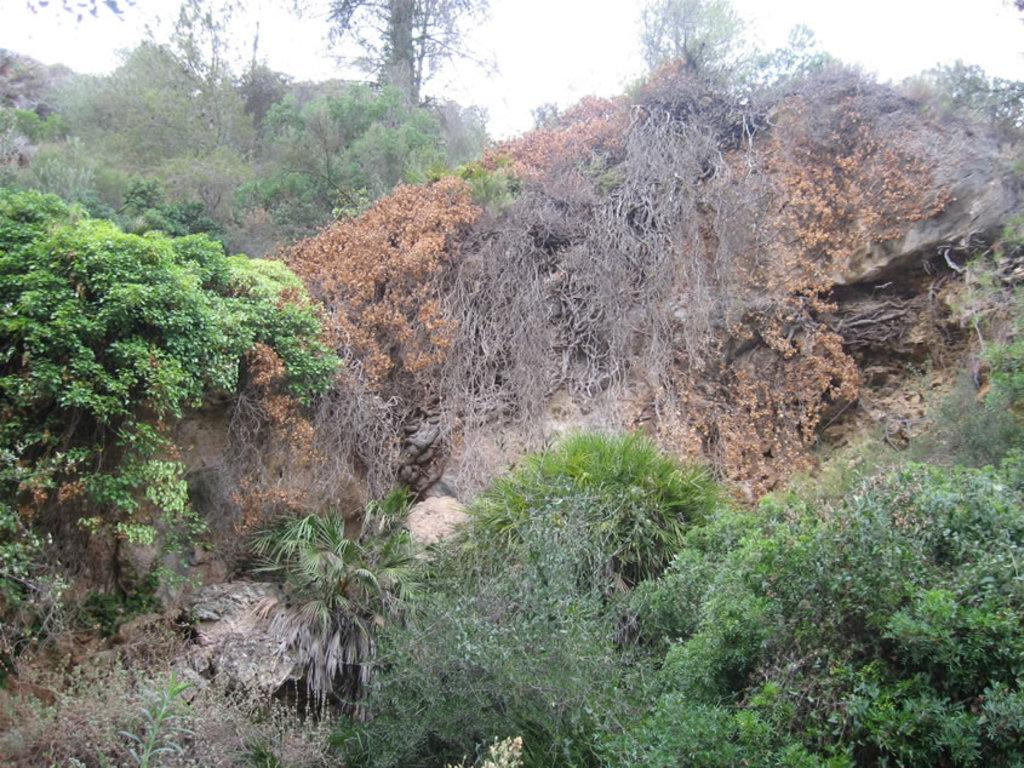What types of vegetation can be seen in the image? There are many trees and plants in the image. Are there any specific types of trees or plants mentioned? Yes, there are dried trees in the image. What can be seen in the background of the image? The sky is visible in the background of the image. What type of lipstick can be seen on the cattle in the image? There are no cattle or lipstick present in the image. 